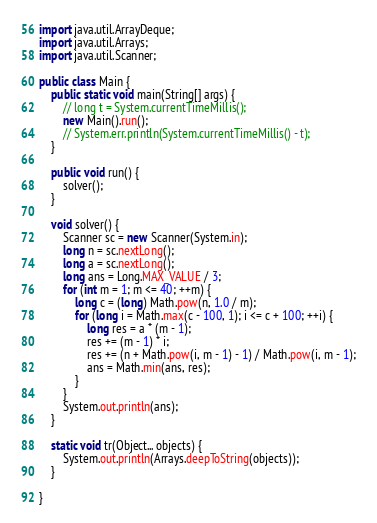Convert code to text. <code><loc_0><loc_0><loc_500><loc_500><_Java_>import java.util.ArrayDeque;
import java.util.Arrays;
import java.util.Scanner;

public class Main {
	public static void main(String[] args) {
		// long t = System.currentTimeMillis();
		new Main().run();
		// System.err.println(System.currentTimeMillis() - t);
	}

	public void run() {
		solver();
	}

	void solver() {
		Scanner sc = new Scanner(System.in);
		long n = sc.nextLong();
		long a = sc.nextLong();
		long ans = Long.MAX_VALUE / 3;
		for (int m = 1; m <= 40; ++m) {
			long c = (long) Math.pow(n, 1.0 / m);
			for (long i = Math.max(c - 100, 1); i <= c + 100; ++i) {
				long res = a * (m - 1);
				res += (m - 1) * i;
				res += (n + Math.pow(i, m - 1) - 1) / Math.pow(i, m - 1);
				ans = Math.min(ans, res);
			}
		}
		System.out.println(ans);
	}

	static void tr(Object... objects) {
		System.out.println(Arrays.deepToString(objects));
	}

}
</code> 